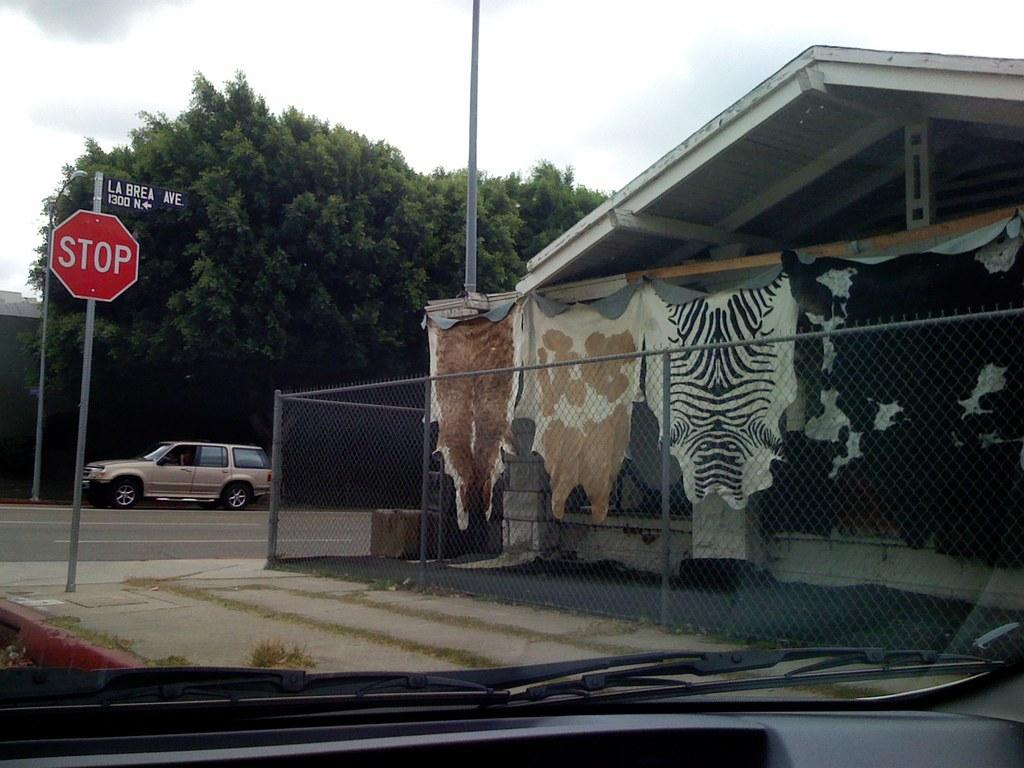What is on the road in the image? There is a vehicle on the road in the image. What structures can be seen in the image? There are poles, sign boards, fences, and a shed in the image. What else is visible in the image? There are clothes, trees, and some objects in the image. What can be seen in the background of the image? The sky is visible in the background of the image. What type of can is depicted in the image? There is no can present in the image. Is there a gate visible in the image? No, there is no gate present in the image. 